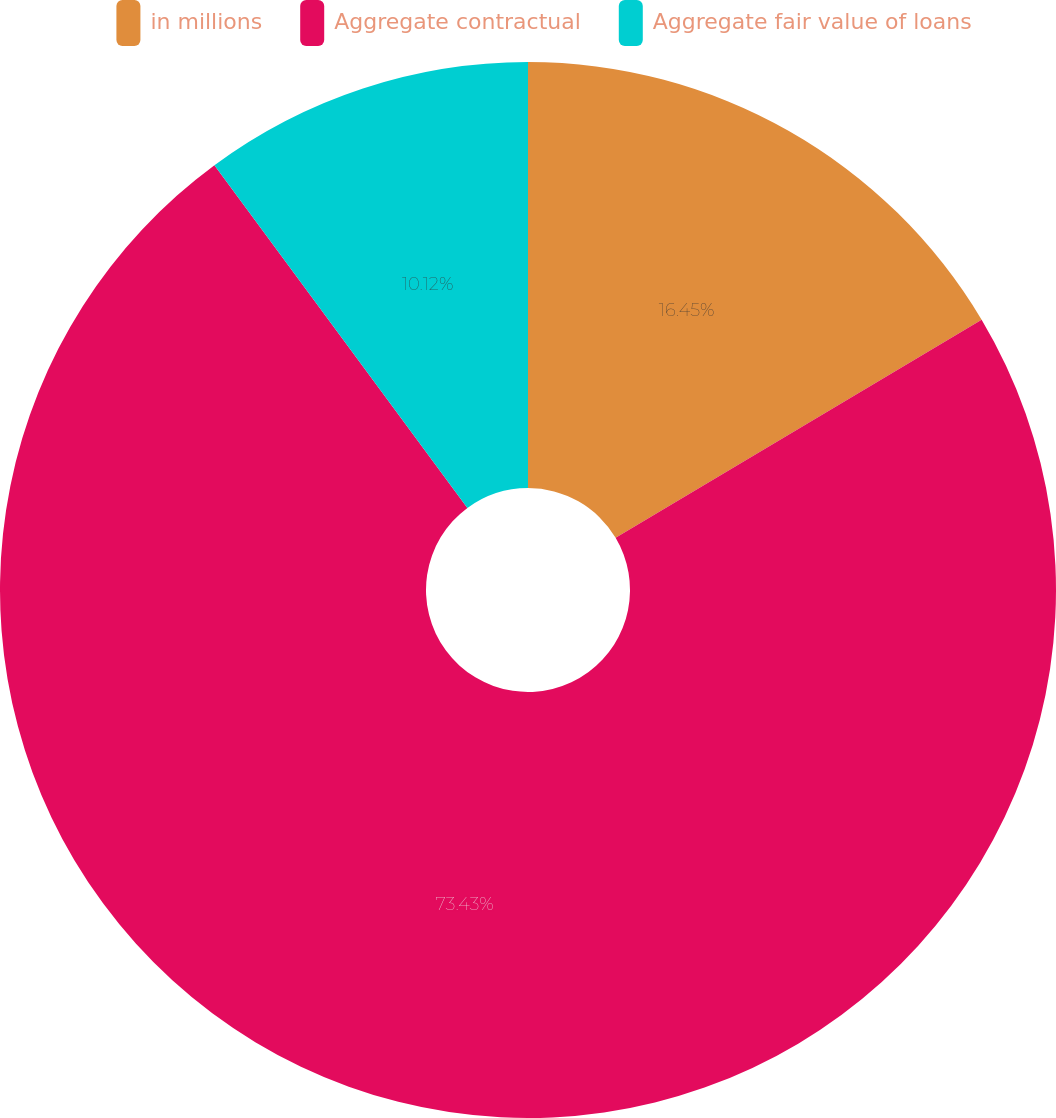Convert chart to OTSL. <chart><loc_0><loc_0><loc_500><loc_500><pie_chart><fcel>in millions<fcel>Aggregate contractual<fcel>Aggregate fair value of loans<nl><fcel>16.45%<fcel>73.43%<fcel>10.12%<nl></chart> 